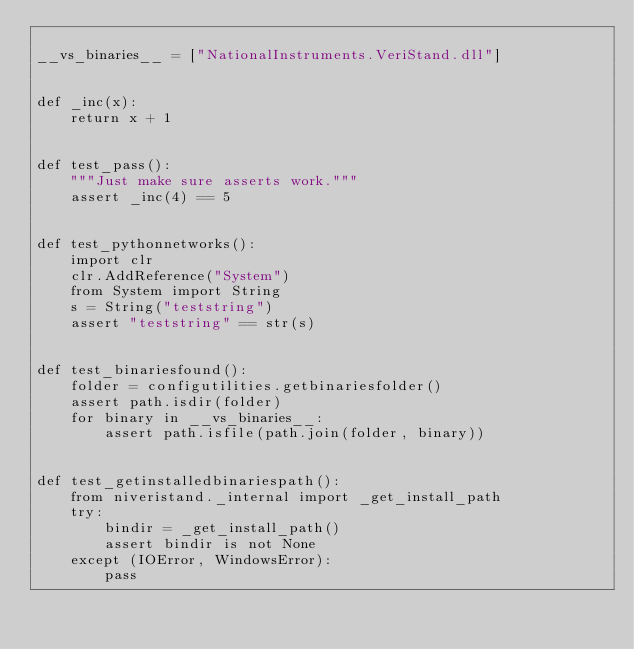Convert code to text. <code><loc_0><loc_0><loc_500><loc_500><_Python_>
__vs_binaries__ = ["NationalInstruments.VeriStand.dll"]


def _inc(x):
    return x + 1


def test_pass():
    """Just make sure asserts work."""
    assert _inc(4) == 5


def test_pythonnetworks():
    import clr
    clr.AddReference("System")
    from System import String
    s = String("teststring")
    assert "teststring" == str(s)


def test_binariesfound():
    folder = configutilities.getbinariesfolder()
    assert path.isdir(folder)
    for binary in __vs_binaries__:
        assert path.isfile(path.join(folder, binary))


def test_getinstalledbinariespath():
    from niveristand._internal import _get_install_path
    try:
        bindir = _get_install_path()
        assert bindir is not None
    except (IOError, WindowsError):
        pass
</code> 